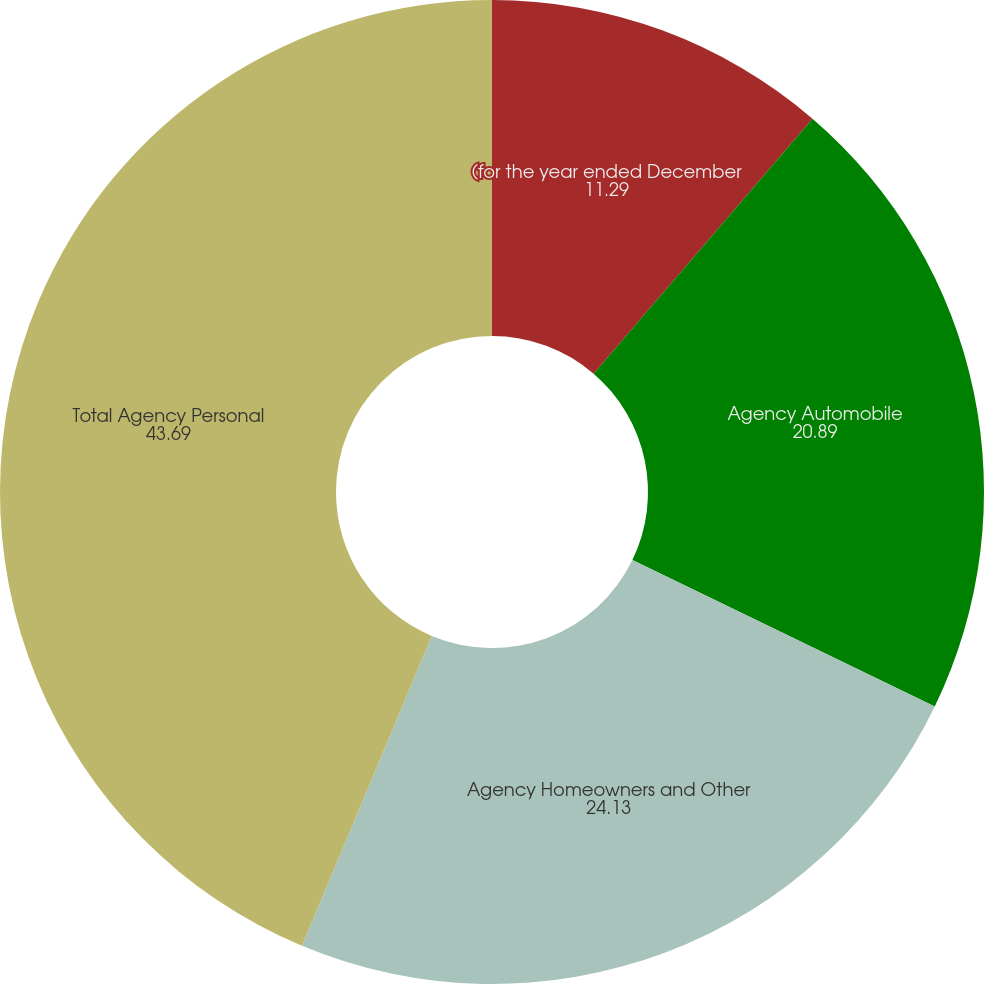<chart> <loc_0><loc_0><loc_500><loc_500><pie_chart><fcel>(for the year ended December<fcel>Agency Automobile<fcel>Agency Homeowners and Other<fcel>Total Agency Personal<nl><fcel>11.29%<fcel>20.89%<fcel>24.13%<fcel>43.69%<nl></chart> 